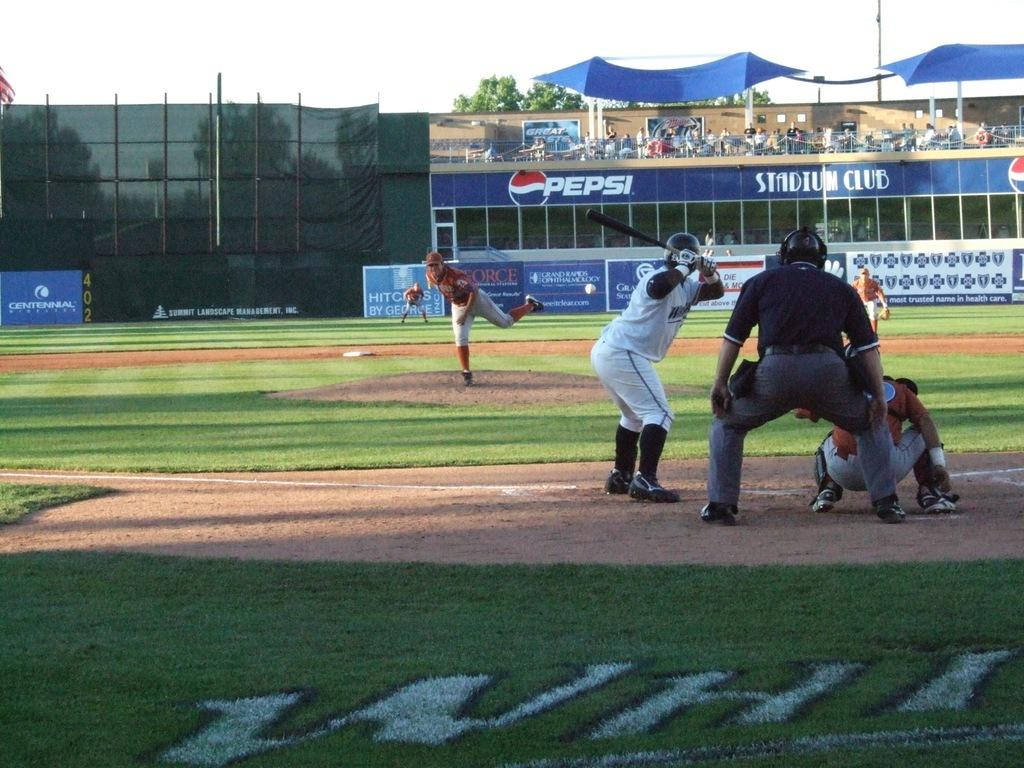<image>
Write a terse but informative summary of the picture. A Pepsi logo can be seen at a baseball diamond. 